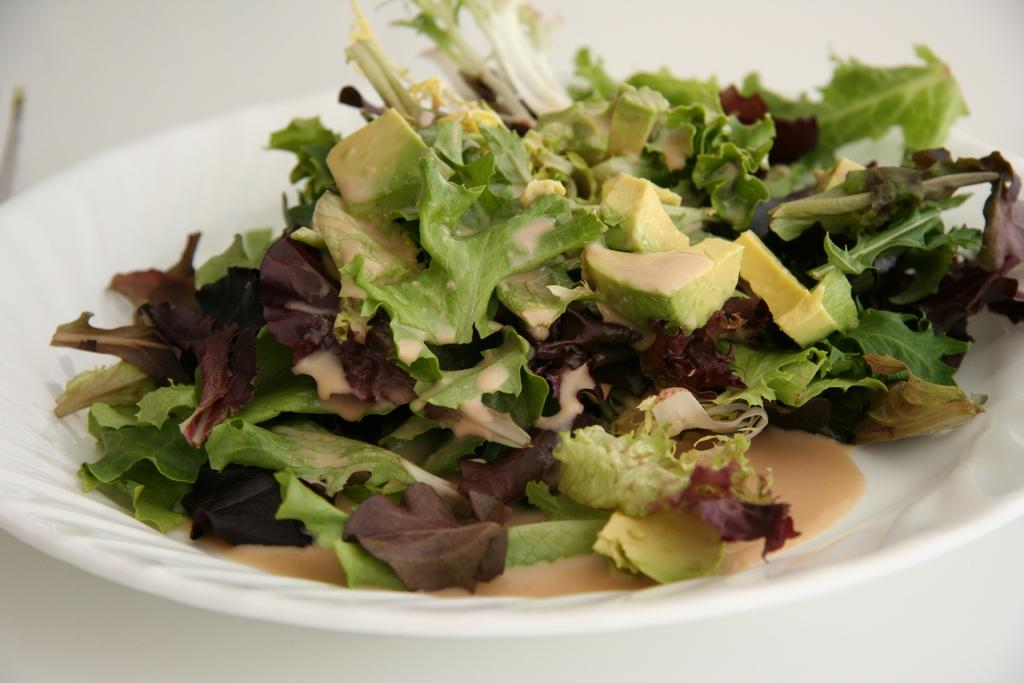What object is present on the plate in the image? There is a white plate in the image. What is on top of the plate? There are leaves on the plate. What else can be seen on the plate besides the leaves? There are food items on the plate. What type of thread is used to tie the knot on the plate? There is no thread or knot present on the plate in the image. 